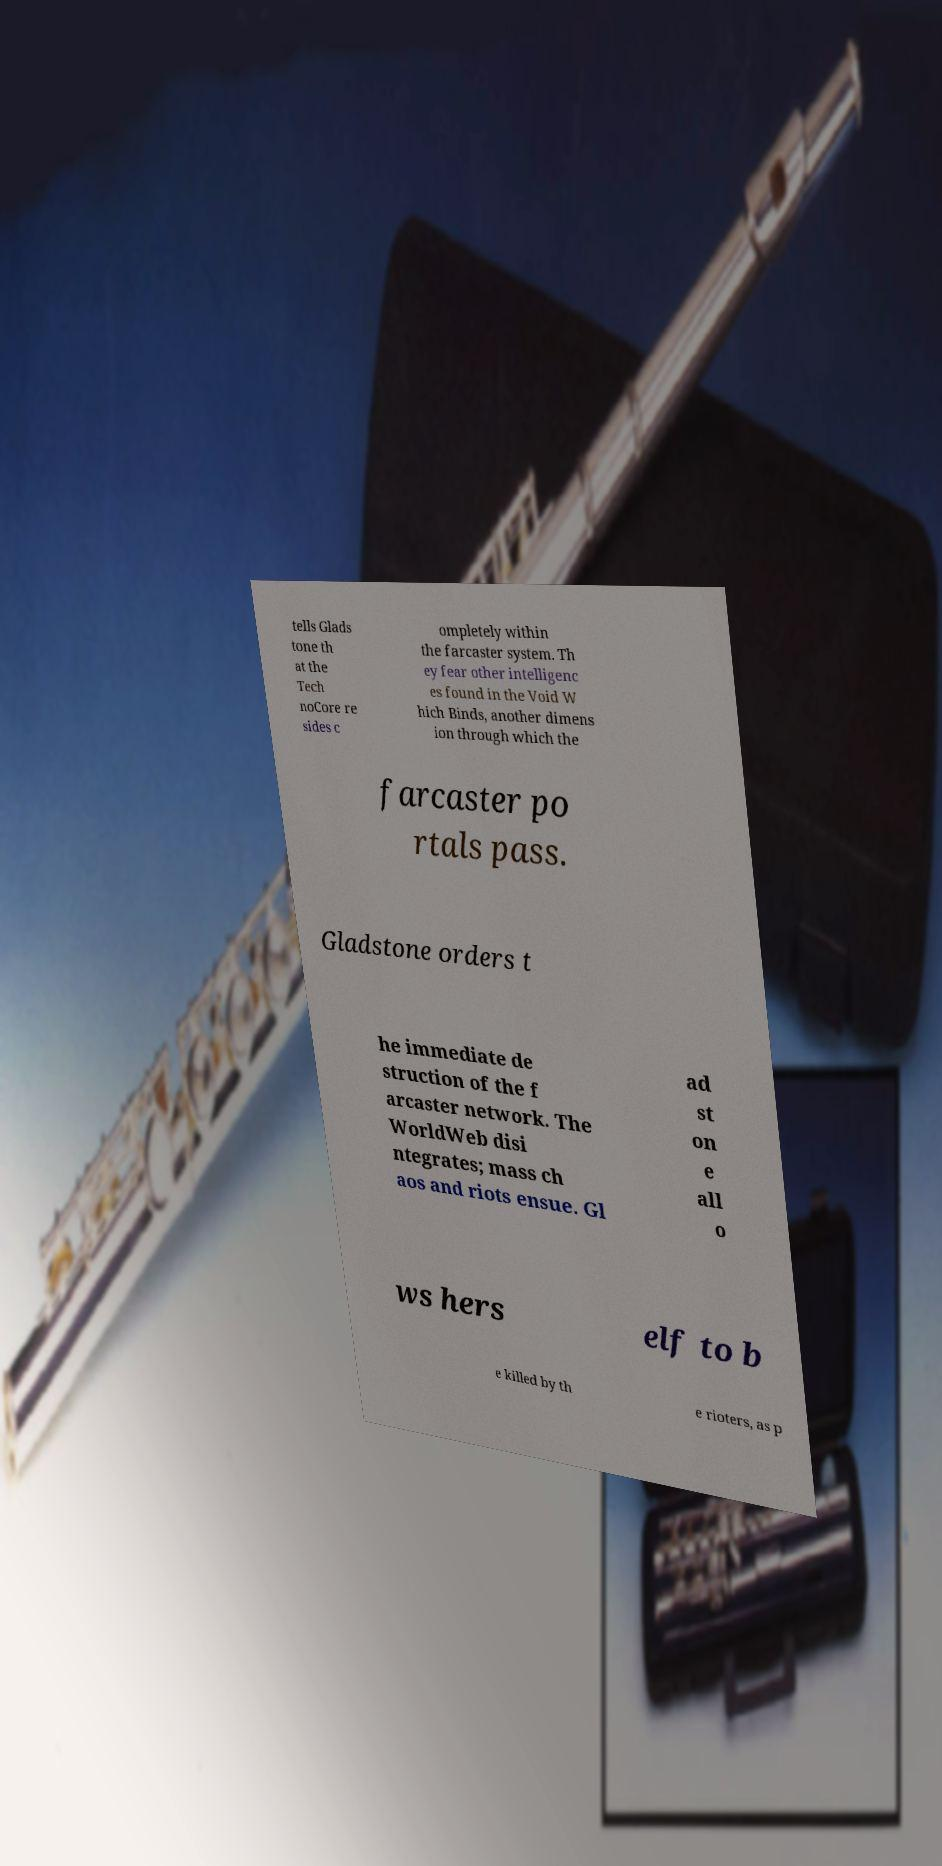There's text embedded in this image that I need extracted. Can you transcribe it verbatim? tells Glads tone th at the Tech noCore re sides c ompletely within the farcaster system. Th ey fear other intelligenc es found in the Void W hich Binds, another dimens ion through which the farcaster po rtals pass. Gladstone orders t he immediate de struction of the f arcaster network. The WorldWeb disi ntegrates; mass ch aos and riots ensue. Gl ad st on e all o ws hers elf to b e killed by th e rioters, as p 